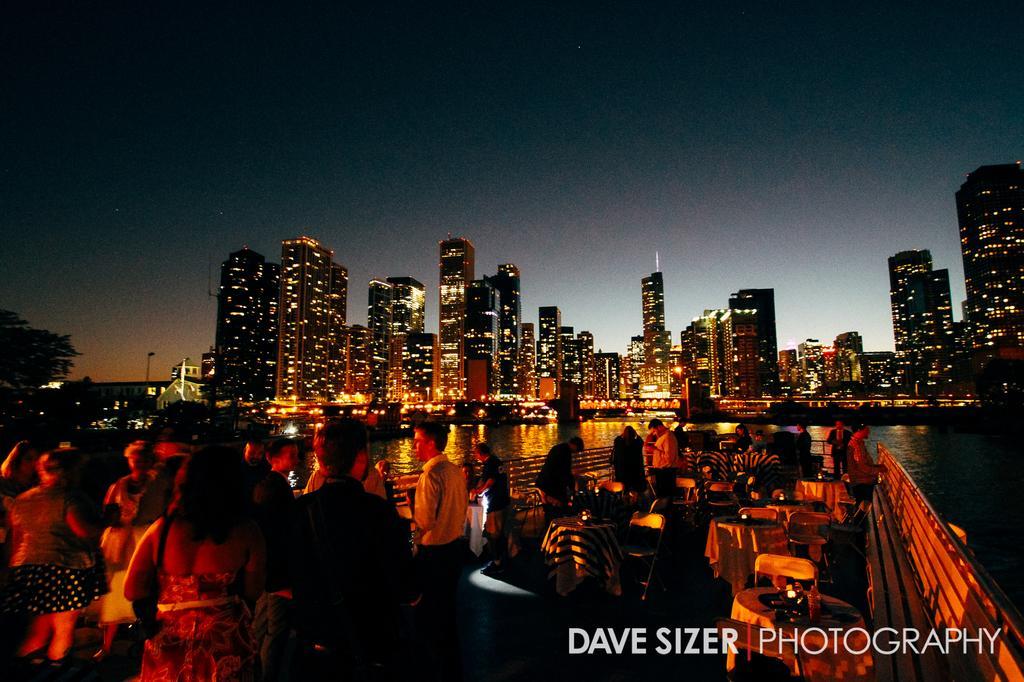How would you summarize this image in a sentence or two? On the bottom left, there is a watermark. On the left side, there are persons standing. On the right side, there are tables arranged. In the background, there is water and there are buildings which are having lights. And the background is dark in color. 